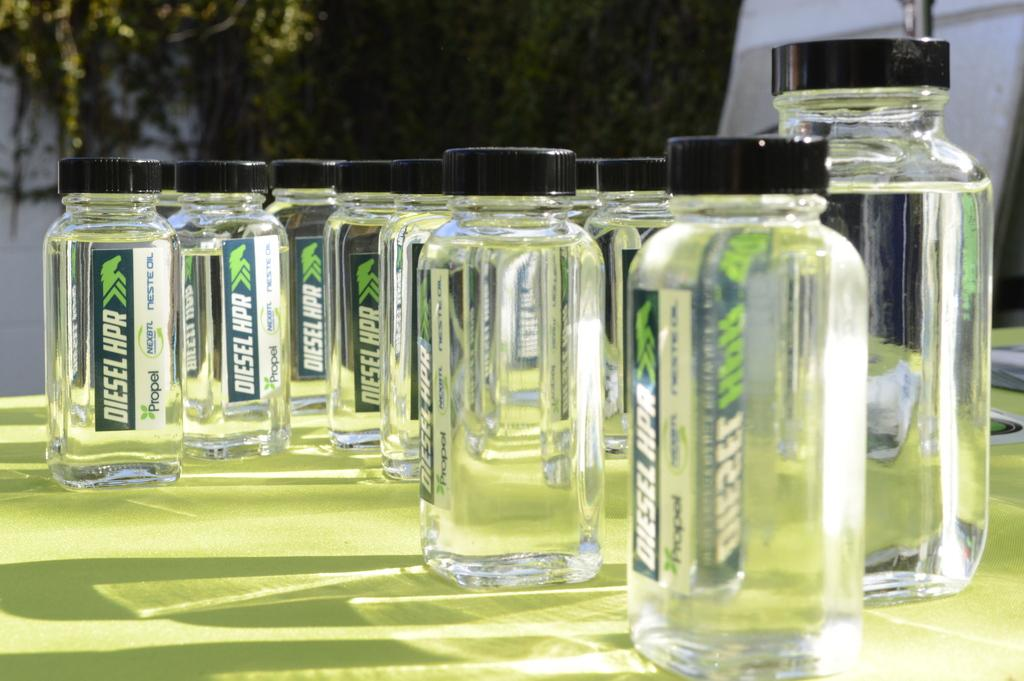<image>
Offer a succinct explanation of the picture presented. A clear bottle of Diesel HPR sits on a green cloth 